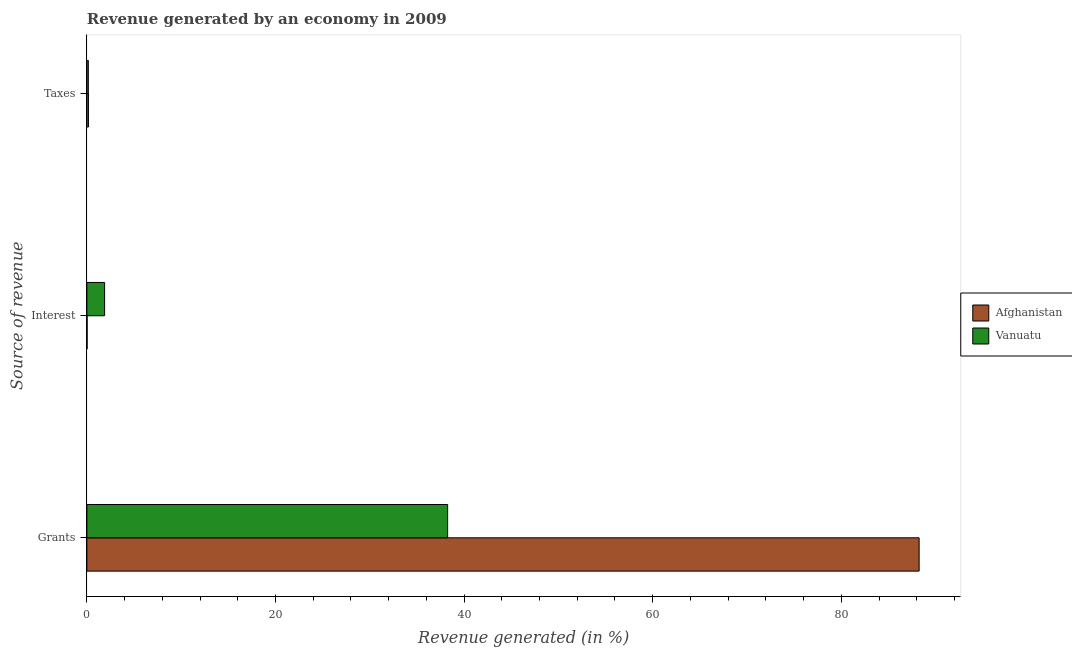How many groups of bars are there?
Provide a short and direct response. 3. How many bars are there on the 2nd tick from the bottom?
Ensure brevity in your answer.  2. What is the label of the 2nd group of bars from the top?
Provide a succinct answer. Interest. What is the percentage of revenue generated by taxes in Vanuatu?
Ensure brevity in your answer.  0.15. Across all countries, what is the maximum percentage of revenue generated by grants?
Provide a short and direct response. 88.25. Across all countries, what is the minimum percentage of revenue generated by interest?
Offer a terse response. 0.02. In which country was the percentage of revenue generated by interest maximum?
Keep it short and to the point. Vanuatu. In which country was the percentage of revenue generated by taxes minimum?
Ensure brevity in your answer.  Vanuatu. What is the total percentage of revenue generated by interest in the graph?
Provide a succinct answer. 1.9. What is the difference between the percentage of revenue generated by interest in Vanuatu and that in Afghanistan?
Provide a succinct answer. 1.86. What is the difference between the percentage of revenue generated by grants in Afghanistan and the percentage of revenue generated by taxes in Vanuatu?
Give a very brief answer. 88.1. What is the average percentage of revenue generated by grants per country?
Your response must be concise. 63.25. What is the difference between the percentage of revenue generated by interest and percentage of revenue generated by grants in Afghanistan?
Offer a very short reply. -88.23. What is the ratio of the percentage of revenue generated by interest in Afghanistan to that in Vanuatu?
Give a very brief answer. 0.01. Is the percentage of revenue generated by interest in Afghanistan less than that in Vanuatu?
Your answer should be compact. Yes. What is the difference between the highest and the second highest percentage of revenue generated by grants?
Your answer should be compact. 50. What is the difference between the highest and the lowest percentage of revenue generated by interest?
Your answer should be very brief. 1.86. Is the sum of the percentage of revenue generated by taxes in Vanuatu and Afghanistan greater than the maximum percentage of revenue generated by interest across all countries?
Ensure brevity in your answer.  No. What does the 1st bar from the top in Interest represents?
Your answer should be compact. Vanuatu. What does the 1st bar from the bottom in Interest represents?
Provide a succinct answer. Afghanistan. What is the difference between two consecutive major ticks on the X-axis?
Provide a short and direct response. 20. Does the graph contain any zero values?
Keep it short and to the point. No. What is the title of the graph?
Your answer should be very brief. Revenue generated by an economy in 2009. Does "Albania" appear as one of the legend labels in the graph?
Offer a terse response. No. What is the label or title of the X-axis?
Offer a very short reply. Revenue generated (in %). What is the label or title of the Y-axis?
Make the answer very short. Source of revenue. What is the Revenue generated (in %) in Afghanistan in Grants?
Provide a short and direct response. 88.25. What is the Revenue generated (in %) of Vanuatu in Grants?
Your response must be concise. 38.25. What is the Revenue generated (in %) in Afghanistan in Interest?
Provide a short and direct response. 0.02. What is the Revenue generated (in %) in Vanuatu in Interest?
Make the answer very short. 1.88. What is the Revenue generated (in %) of Afghanistan in Taxes?
Your answer should be compact. 0.17. What is the Revenue generated (in %) of Vanuatu in Taxes?
Ensure brevity in your answer.  0.15. Across all Source of revenue, what is the maximum Revenue generated (in %) of Afghanistan?
Your response must be concise. 88.25. Across all Source of revenue, what is the maximum Revenue generated (in %) of Vanuatu?
Your answer should be compact. 38.25. Across all Source of revenue, what is the minimum Revenue generated (in %) of Afghanistan?
Offer a terse response. 0.02. Across all Source of revenue, what is the minimum Revenue generated (in %) of Vanuatu?
Your answer should be compact. 0.15. What is the total Revenue generated (in %) in Afghanistan in the graph?
Provide a succinct answer. 88.44. What is the total Revenue generated (in %) of Vanuatu in the graph?
Your answer should be very brief. 40.29. What is the difference between the Revenue generated (in %) in Afghanistan in Grants and that in Interest?
Your answer should be very brief. 88.23. What is the difference between the Revenue generated (in %) in Vanuatu in Grants and that in Interest?
Your response must be concise. 36.37. What is the difference between the Revenue generated (in %) of Afghanistan in Grants and that in Taxes?
Ensure brevity in your answer.  88.09. What is the difference between the Revenue generated (in %) of Vanuatu in Grants and that in Taxes?
Your response must be concise. 38.1. What is the difference between the Revenue generated (in %) of Afghanistan in Interest and that in Taxes?
Give a very brief answer. -0.14. What is the difference between the Revenue generated (in %) in Vanuatu in Interest and that in Taxes?
Offer a terse response. 1.73. What is the difference between the Revenue generated (in %) in Afghanistan in Grants and the Revenue generated (in %) in Vanuatu in Interest?
Provide a succinct answer. 86.37. What is the difference between the Revenue generated (in %) of Afghanistan in Grants and the Revenue generated (in %) of Vanuatu in Taxes?
Make the answer very short. 88.1. What is the difference between the Revenue generated (in %) in Afghanistan in Interest and the Revenue generated (in %) in Vanuatu in Taxes?
Your response must be concise. -0.13. What is the average Revenue generated (in %) in Afghanistan per Source of revenue?
Make the answer very short. 29.48. What is the average Revenue generated (in %) of Vanuatu per Source of revenue?
Provide a succinct answer. 13.43. What is the difference between the Revenue generated (in %) in Afghanistan and Revenue generated (in %) in Vanuatu in Grants?
Offer a terse response. 50. What is the difference between the Revenue generated (in %) of Afghanistan and Revenue generated (in %) of Vanuatu in Interest?
Ensure brevity in your answer.  -1.86. What is the difference between the Revenue generated (in %) of Afghanistan and Revenue generated (in %) of Vanuatu in Taxes?
Offer a terse response. 0.01. What is the ratio of the Revenue generated (in %) of Afghanistan in Grants to that in Interest?
Offer a very short reply. 3655.77. What is the ratio of the Revenue generated (in %) in Vanuatu in Grants to that in Interest?
Keep it short and to the point. 20.34. What is the ratio of the Revenue generated (in %) in Afghanistan in Grants to that in Taxes?
Keep it short and to the point. 530.97. What is the ratio of the Revenue generated (in %) of Vanuatu in Grants to that in Taxes?
Keep it short and to the point. 249.61. What is the ratio of the Revenue generated (in %) of Afghanistan in Interest to that in Taxes?
Make the answer very short. 0.15. What is the ratio of the Revenue generated (in %) of Vanuatu in Interest to that in Taxes?
Keep it short and to the point. 12.27. What is the difference between the highest and the second highest Revenue generated (in %) of Afghanistan?
Offer a terse response. 88.09. What is the difference between the highest and the second highest Revenue generated (in %) of Vanuatu?
Provide a short and direct response. 36.37. What is the difference between the highest and the lowest Revenue generated (in %) in Afghanistan?
Offer a very short reply. 88.23. What is the difference between the highest and the lowest Revenue generated (in %) of Vanuatu?
Offer a very short reply. 38.1. 